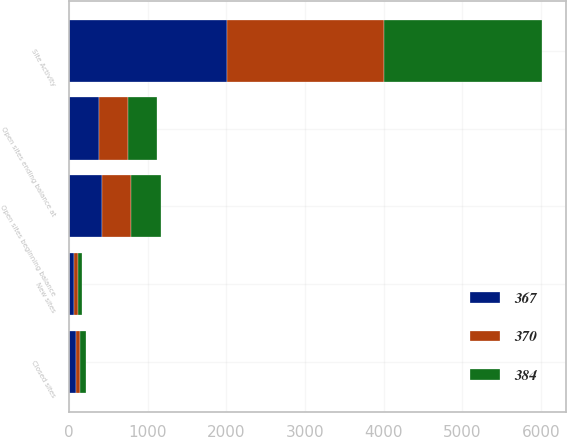<chart> <loc_0><loc_0><loc_500><loc_500><stacked_bar_chart><ecel><fcel>Site Activity<fcel>Open sites beginning balance<fcel>New sites<fcel>Closed sites<fcel>Open sites ending balance at<nl><fcel>370<fcel>2006<fcel>370<fcel>50<fcel>53<fcel>367<nl><fcel>384<fcel>2005<fcel>384<fcel>56<fcel>70<fcel>370<nl><fcel>367<fcel>2004<fcel>417<fcel>59<fcel>92<fcel>384<nl></chart> 